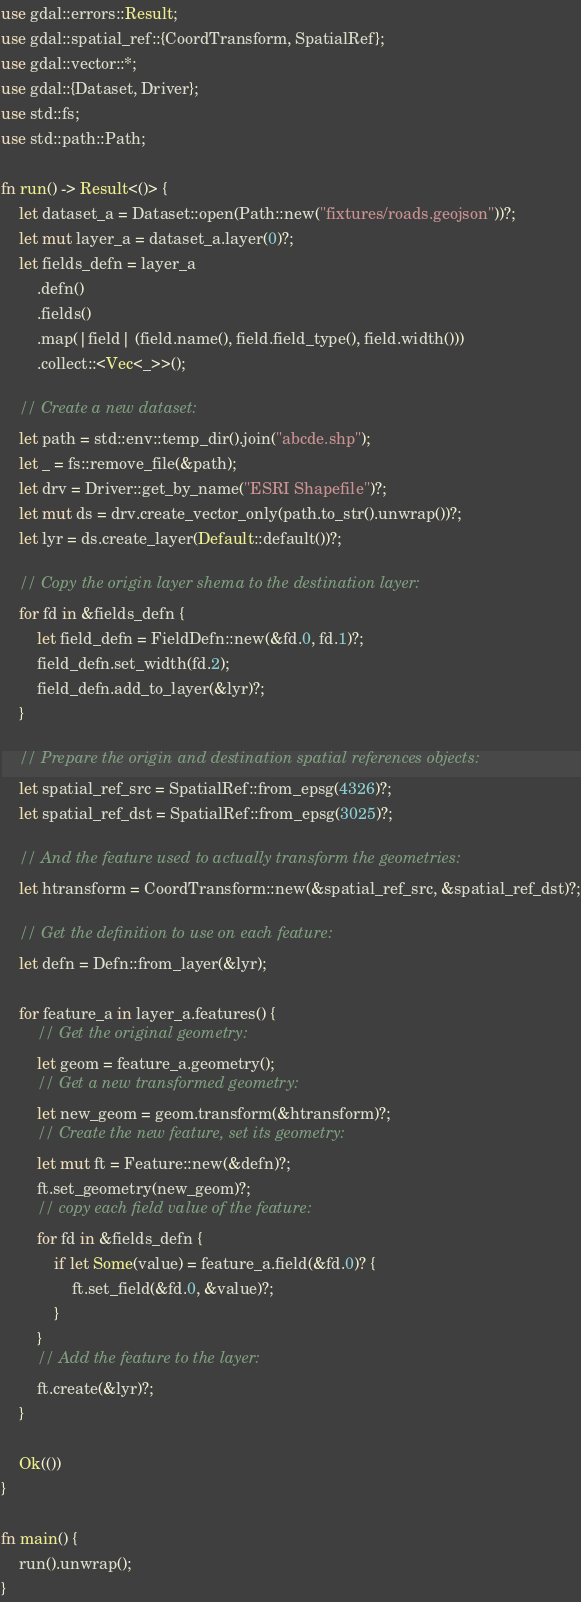Convert code to text. <code><loc_0><loc_0><loc_500><loc_500><_Rust_>use gdal::errors::Result;
use gdal::spatial_ref::{CoordTransform, SpatialRef};
use gdal::vector::*;
use gdal::{Dataset, Driver};
use std::fs;
use std::path::Path;

fn run() -> Result<()> {
    let dataset_a = Dataset::open(Path::new("fixtures/roads.geojson"))?;
    let mut layer_a = dataset_a.layer(0)?;
    let fields_defn = layer_a
        .defn()
        .fields()
        .map(|field| (field.name(), field.field_type(), field.width()))
        .collect::<Vec<_>>();

    // Create a new dataset:
    let path = std::env::temp_dir().join("abcde.shp");
    let _ = fs::remove_file(&path);
    let drv = Driver::get_by_name("ESRI Shapefile")?;
    let mut ds = drv.create_vector_only(path.to_str().unwrap())?;
    let lyr = ds.create_layer(Default::default())?;

    // Copy the origin layer shema to the destination layer:
    for fd in &fields_defn {
        let field_defn = FieldDefn::new(&fd.0, fd.1)?;
        field_defn.set_width(fd.2);
        field_defn.add_to_layer(&lyr)?;
    }

    // Prepare the origin and destination spatial references objects:
    let spatial_ref_src = SpatialRef::from_epsg(4326)?;
    let spatial_ref_dst = SpatialRef::from_epsg(3025)?;

    // And the feature used to actually transform the geometries:
    let htransform = CoordTransform::new(&spatial_ref_src, &spatial_ref_dst)?;

    // Get the definition to use on each feature:
    let defn = Defn::from_layer(&lyr);

    for feature_a in layer_a.features() {
        // Get the original geometry:
        let geom = feature_a.geometry();
        // Get a new transformed geometry:
        let new_geom = geom.transform(&htransform)?;
        // Create the new feature, set its geometry:
        let mut ft = Feature::new(&defn)?;
        ft.set_geometry(new_geom)?;
        // copy each field value of the feature:
        for fd in &fields_defn {
            if let Some(value) = feature_a.field(&fd.0)? {
                ft.set_field(&fd.0, &value)?;
            }
        }
        // Add the feature to the layer:
        ft.create(&lyr)?;
    }

    Ok(())
}

fn main() {
    run().unwrap();
}
</code> 